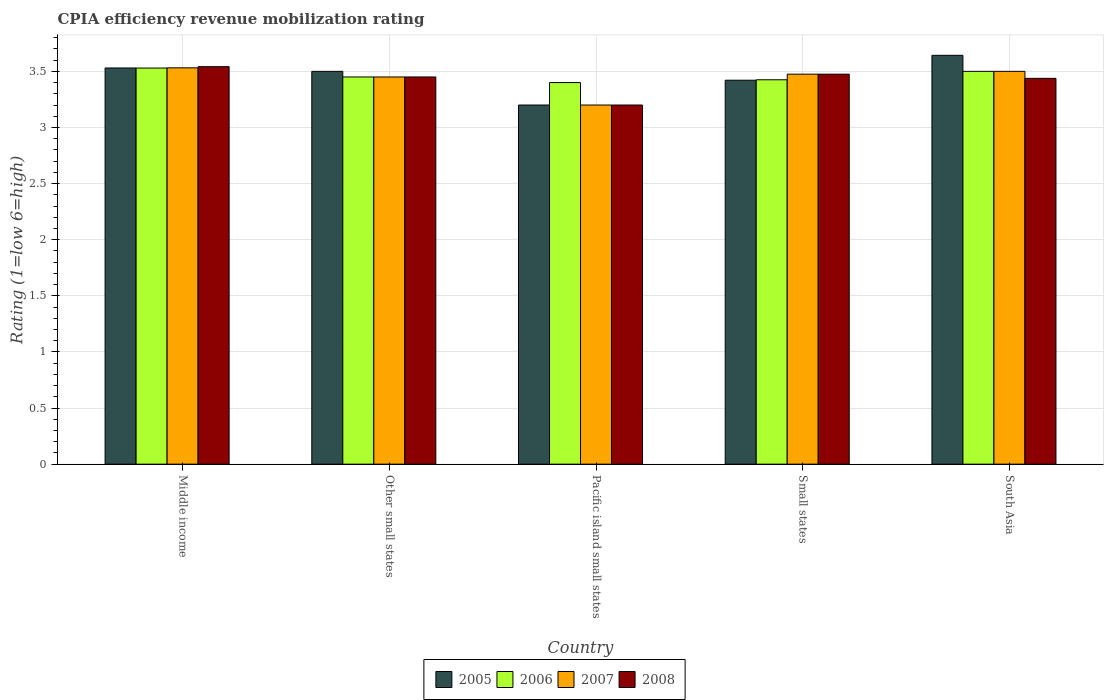How many different coloured bars are there?
Provide a succinct answer. 4. How many groups of bars are there?
Keep it short and to the point. 5. Are the number of bars on each tick of the X-axis equal?
Your response must be concise. Yes. What is the label of the 3rd group of bars from the left?
Offer a very short reply. Pacific island small states. In how many cases, is the number of bars for a given country not equal to the number of legend labels?
Your response must be concise. 0. Across all countries, what is the maximum CPIA rating in 2006?
Offer a terse response. 3.53. In which country was the CPIA rating in 2007 minimum?
Your response must be concise. Pacific island small states. What is the total CPIA rating in 2005 in the graph?
Keep it short and to the point. 17.29. What is the difference between the CPIA rating in 2006 in Middle income and that in Pacific island small states?
Your answer should be compact. 0.13. What is the difference between the CPIA rating in 2006 in South Asia and the CPIA rating in 2008 in Other small states?
Your answer should be compact. 0.05. What is the average CPIA rating in 2005 per country?
Offer a terse response. 3.46. What is the ratio of the CPIA rating in 2005 in Small states to that in South Asia?
Provide a short and direct response. 0.94. Is the CPIA rating in 2005 in Middle income less than that in South Asia?
Your response must be concise. Yes. Is the difference between the CPIA rating in 2008 in Middle income and Pacific island small states greater than the difference between the CPIA rating in 2007 in Middle income and Pacific island small states?
Provide a succinct answer. Yes. What is the difference between the highest and the second highest CPIA rating in 2006?
Ensure brevity in your answer.  -0.03. What is the difference between the highest and the lowest CPIA rating in 2008?
Your answer should be very brief. 0.34. In how many countries, is the CPIA rating in 2006 greater than the average CPIA rating in 2006 taken over all countries?
Provide a short and direct response. 2. What does the 1st bar from the left in Small states represents?
Ensure brevity in your answer.  2005. What does the 4th bar from the right in South Asia represents?
Your response must be concise. 2005. Is it the case that in every country, the sum of the CPIA rating in 2006 and CPIA rating in 2005 is greater than the CPIA rating in 2007?
Your response must be concise. Yes. What is the difference between two consecutive major ticks on the Y-axis?
Your answer should be very brief. 0.5. Are the values on the major ticks of Y-axis written in scientific E-notation?
Your response must be concise. No. Does the graph contain grids?
Your response must be concise. Yes. Where does the legend appear in the graph?
Provide a short and direct response. Bottom center. How are the legend labels stacked?
Provide a short and direct response. Horizontal. What is the title of the graph?
Provide a short and direct response. CPIA efficiency revenue mobilization rating. What is the label or title of the Y-axis?
Provide a short and direct response. Rating (1=low 6=high). What is the Rating (1=low 6=high) in 2005 in Middle income?
Your answer should be very brief. 3.53. What is the Rating (1=low 6=high) of 2006 in Middle income?
Provide a succinct answer. 3.53. What is the Rating (1=low 6=high) of 2007 in Middle income?
Keep it short and to the point. 3.53. What is the Rating (1=low 6=high) in 2008 in Middle income?
Offer a terse response. 3.54. What is the Rating (1=low 6=high) of 2006 in Other small states?
Your answer should be compact. 3.45. What is the Rating (1=low 6=high) in 2007 in Other small states?
Your answer should be compact. 3.45. What is the Rating (1=low 6=high) in 2008 in Other small states?
Provide a succinct answer. 3.45. What is the Rating (1=low 6=high) in 2005 in Pacific island small states?
Make the answer very short. 3.2. What is the Rating (1=low 6=high) of 2007 in Pacific island small states?
Your response must be concise. 3.2. What is the Rating (1=low 6=high) of 2008 in Pacific island small states?
Your answer should be compact. 3.2. What is the Rating (1=low 6=high) of 2005 in Small states?
Provide a succinct answer. 3.42. What is the Rating (1=low 6=high) in 2006 in Small states?
Provide a succinct answer. 3.42. What is the Rating (1=low 6=high) of 2007 in Small states?
Offer a terse response. 3.48. What is the Rating (1=low 6=high) in 2008 in Small states?
Ensure brevity in your answer.  3.48. What is the Rating (1=low 6=high) of 2005 in South Asia?
Make the answer very short. 3.64. What is the Rating (1=low 6=high) of 2006 in South Asia?
Your answer should be compact. 3.5. What is the Rating (1=low 6=high) of 2008 in South Asia?
Offer a very short reply. 3.44. Across all countries, what is the maximum Rating (1=low 6=high) of 2005?
Provide a short and direct response. 3.64. Across all countries, what is the maximum Rating (1=low 6=high) in 2006?
Provide a succinct answer. 3.53. Across all countries, what is the maximum Rating (1=low 6=high) of 2007?
Offer a terse response. 3.53. Across all countries, what is the maximum Rating (1=low 6=high) of 2008?
Offer a terse response. 3.54. Across all countries, what is the minimum Rating (1=low 6=high) in 2006?
Make the answer very short. 3.4. What is the total Rating (1=low 6=high) of 2005 in the graph?
Make the answer very short. 17.29. What is the total Rating (1=low 6=high) of 2006 in the graph?
Your answer should be very brief. 17.3. What is the total Rating (1=low 6=high) of 2007 in the graph?
Your answer should be very brief. 17.16. What is the total Rating (1=low 6=high) in 2008 in the graph?
Your answer should be very brief. 17.1. What is the difference between the Rating (1=low 6=high) of 2006 in Middle income and that in Other small states?
Your answer should be compact. 0.08. What is the difference between the Rating (1=low 6=high) of 2007 in Middle income and that in Other small states?
Give a very brief answer. 0.08. What is the difference between the Rating (1=low 6=high) in 2008 in Middle income and that in Other small states?
Provide a succinct answer. 0.09. What is the difference between the Rating (1=low 6=high) of 2005 in Middle income and that in Pacific island small states?
Your response must be concise. 0.33. What is the difference between the Rating (1=low 6=high) in 2006 in Middle income and that in Pacific island small states?
Make the answer very short. 0.13. What is the difference between the Rating (1=low 6=high) of 2007 in Middle income and that in Pacific island small states?
Your answer should be very brief. 0.33. What is the difference between the Rating (1=low 6=high) in 2008 in Middle income and that in Pacific island small states?
Keep it short and to the point. 0.34. What is the difference between the Rating (1=low 6=high) of 2005 in Middle income and that in Small states?
Ensure brevity in your answer.  0.11. What is the difference between the Rating (1=low 6=high) of 2006 in Middle income and that in Small states?
Offer a very short reply. 0.1. What is the difference between the Rating (1=low 6=high) of 2007 in Middle income and that in Small states?
Your answer should be very brief. 0.06. What is the difference between the Rating (1=low 6=high) of 2008 in Middle income and that in Small states?
Make the answer very short. 0.07. What is the difference between the Rating (1=low 6=high) of 2005 in Middle income and that in South Asia?
Provide a succinct answer. -0.11. What is the difference between the Rating (1=low 6=high) of 2006 in Middle income and that in South Asia?
Ensure brevity in your answer.  0.03. What is the difference between the Rating (1=low 6=high) in 2007 in Middle income and that in South Asia?
Make the answer very short. 0.03. What is the difference between the Rating (1=low 6=high) in 2008 in Middle income and that in South Asia?
Your response must be concise. 0.1. What is the difference between the Rating (1=low 6=high) of 2006 in Other small states and that in Pacific island small states?
Provide a succinct answer. 0.05. What is the difference between the Rating (1=low 6=high) in 2008 in Other small states and that in Pacific island small states?
Give a very brief answer. 0.25. What is the difference between the Rating (1=low 6=high) in 2005 in Other small states and that in Small states?
Keep it short and to the point. 0.08. What is the difference between the Rating (1=low 6=high) of 2006 in Other small states and that in Small states?
Your response must be concise. 0.03. What is the difference between the Rating (1=low 6=high) of 2007 in Other small states and that in Small states?
Keep it short and to the point. -0.03. What is the difference between the Rating (1=low 6=high) of 2008 in Other small states and that in Small states?
Give a very brief answer. -0.03. What is the difference between the Rating (1=low 6=high) in 2005 in Other small states and that in South Asia?
Offer a terse response. -0.14. What is the difference between the Rating (1=low 6=high) in 2006 in Other small states and that in South Asia?
Offer a terse response. -0.05. What is the difference between the Rating (1=low 6=high) of 2007 in Other small states and that in South Asia?
Your answer should be very brief. -0.05. What is the difference between the Rating (1=low 6=high) in 2008 in Other small states and that in South Asia?
Give a very brief answer. 0.01. What is the difference between the Rating (1=low 6=high) of 2005 in Pacific island small states and that in Small states?
Provide a succinct answer. -0.22. What is the difference between the Rating (1=low 6=high) in 2006 in Pacific island small states and that in Small states?
Offer a very short reply. -0.03. What is the difference between the Rating (1=low 6=high) of 2007 in Pacific island small states and that in Small states?
Your response must be concise. -0.28. What is the difference between the Rating (1=low 6=high) in 2008 in Pacific island small states and that in Small states?
Offer a very short reply. -0.28. What is the difference between the Rating (1=low 6=high) of 2005 in Pacific island small states and that in South Asia?
Your answer should be compact. -0.44. What is the difference between the Rating (1=low 6=high) of 2008 in Pacific island small states and that in South Asia?
Keep it short and to the point. -0.24. What is the difference between the Rating (1=low 6=high) of 2005 in Small states and that in South Asia?
Ensure brevity in your answer.  -0.22. What is the difference between the Rating (1=low 6=high) of 2006 in Small states and that in South Asia?
Provide a short and direct response. -0.07. What is the difference between the Rating (1=low 6=high) in 2007 in Small states and that in South Asia?
Ensure brevity in your answer.  -0.03. What is the difference between the Rating (1=low 6=high) in 2008 in Small states and that in South Asia?
Provide a short and direct response. 0.04. What is the difference between the Rating (1=low 6=high) in 2005 in Middle income and the Rating (1=low 6=high) in 2006 in Other small states?
Your answer should be compact. 0.08. What is the difference between the Rating (1=low 6=high) of 2005 in Middle income and the Rating (1=low 6=high) of 2007 in Other small states?
Give a very brief answer. 0.08. What is the difference between the Rating (1=low 6=high) in 2006 in Middle income and the Rating (1=low 6=high) in 2007 in Other small states?
Your answer should be compact. 0.08. What is the difference between the Rating (1=low 6=high) of 2006 in Middle income and the Rating (1=low 6=high) of 2008 in Other small states?
Keep it short and to the point. 0.08. What is the difference between the Rating (1=low 6=high) in 2007 in Middle income and the Rating (1=low 6=high) in 2008 in Other small states?
Offer a very short reply. 0.08. What is the difference between the Rating (1=low 6=high) in 2005 in Middle income and the Rating (1=low 6=high) in 2006 in Pacific island small states?
Your answer should be very brief. 0.13. What is the difference between the Rating (1=low 6=high) in 2005 in Middle income and the Rating (1=low 6=high) in 2007 in Pacific island small states?
Offer a very short reply. 0.33. What is the difference between the Rating (1=low 6=high) in 2005 in Middle income and the Rating (1=low 6=high) in 2008 in Pacific island small states?
Your response must be concise. 0.33. What is the difference between the Rating (1=low 6=high) of 2006 in Middle income and the Rating (1=low 6=high) of 2007 in Pacific island small states?
Make the answer very short. 0.33. What is the difference between the Rating (1=low 6=high) in 2006 in Middle income and the Rating (1=low 6=high) in 2008 in Pacific island small states?
Provide a succinct answer. 0.33. What is the difference between the Rating (1=low 6=high) in 2007 in Middle income and the Rating (1=low 6=high) in 2008 in Pacific island small states?
Your response must be concise. 0.33. What is the difference between the Rating (1=low 6=high) of 2005 in Middle income and the Rating (1=low 6=high) of 2006 in Small states?
Offer a terse response. 0.1. What is the difference between the Rating (1=low 6=high) in 2005 in Middle income and the Rating (1=low 6=high) in 2007 in Small states?
Make the answer very short. 0.06. What is the difference between the Rating (1=low 6=high) in 2005 in Middle income and the Rating (1=low 6=high) in 2008 in Small states?
Offer a very short reply. 0.06. What is the difference between the Rating (1=low 6=high) of 2006 in Middle income and the Rating (1=low 6=high) of 2007 in Small states?
Offer a very short reply. 0.05. What is the difference between the Rating (1=low 6=high) of 2006 in Middle income and the Rating (1=low 6=high) of 2008 in Small states?
Provide a succinct answer. 0.05. What is the difference between the Rating (1=low 6=high) in 2007 in Middle income and the Rating (1=low 6=high) in 2008 in Small states?
Give a very brief answer. 0.06. What is the difference between the Rating (1=low 6=high) of 2005 in Middle income and the Rating (1=low 6=high) of 2006 in South Asia?
Ensure brevity in your answer.  0.03. What is the difference between the Rating (1=low 6=high) of 2005 in Middle income and the Rating (1=low 6=high) of 2007 in South Asia?
Your answer should be compact. 0.03. What is the difference between the Rating (1=low 6=high) of 2005 in Middle income and the Rating (1=low 6=high) of 2008 in South Asia?
Your answer should be compact. 0.09. What is the difference between the Rating (1=low 6=high) of 2006 in Middle income and the Rating (1=low 6=high) of 2007 in South Asia?
Offer a terse response. 0.03. What is the difference between the Rating (1=low 6=high) in 2006 in Middle income and the Rating (1=low 6=high) in 2008 in South Asia?
Give a very brief answer. 0.09. What is the difference between the Rating (1=low 6=high) in 2007 in Middle income and the Rating (1=low 6=high) in 2008 in South Asia?
Your answer should be compact. 0.09. What is the difference between the Rating (1=low 6=high) of 2005 in Other small states and the Rating (1=low 6=high) of 2006 in Pacific island small states?
Give a very brief answer. 0.1. What is the difference between the Rating (1=low 6=high) in 2005 in Other small states and the Rating (1=low 6=high) in 2007 in Pacific island small states?
Provide a succinct answer. 0.3. What is the difference between the Rating (1=low 6=high) in 2006 in Other small states and the Rating (1=low 6=high) in 2008 in Pacific island small states?
Keep it short and to the point. 0.25. What is the difference between the Rating (1=low 6=high) in 2007 in Other small states and the Rating (1=low 6=high) in 2008 in Pacific island small states?
Ensure brevity in your answer.  0.25. What is the difference between the Rating (1=low 6=high) of 2005 in Other small states and the Rating (1=low 6=high) of 2006 in Small states?
Make the answer very short. 0.07. What is the difference between the Rating (1=low 6=high) of 2005 in Other small states and the Rating (1=low 6=high) of 2007 in Small states?
Offer a terse response. 0.03. What is the difference between the Rating (1=low 6=high) of 2005 in Other small states and the Rating (1=low 6=high) of 2008 in Small states?
Your answer should be very brief. 0.03. What is the difference between the Rating (1=low 6=high) in 2006 in Other small states and the Rating (1=low 6=high) in 2007 in Small states?
Provide a short and direct response. -0.03. What is the difference between the Rating (1=low 6=high) in 2006 in Other small states and the Rating (1=low 6=high) in 2008 in Small states?
Provide a short and direct response. -0.03. What is the difference between the Rating (1=low 6=high) in 2007 in Other small states and the Rating (1=low 6=high) in 2008 in Small states?
Your answer should be compact. -0.03. What is the difference between the Rating (1=low 6=high) in 2005 in Other small states and the Rating (1=low 6=high) in 2006 in South Asia?
Offer a very short reply. 0. What is the difference between the Rating (1=low 6=high) in 2005 in Other small states and the Rating (1=low 6=high) in 2007 in South Asia?
Provide a succinct answer. 0. What is the difference between the Rating (1=low 6=high) of 2005 in Other small states and the Rating (1=low 6=high) of 2008 in South Asia?
Make the answer very short. 0.06. What is the difference between the Rating (1=low 6=high) in 2006 in Other small states and the Rating (1=low 6=high) in 2008 in South Asia?
Your answer should be compact. 0.01. What is the difference between the Rating (1=low 6=high) in 2007 in Other small states and the Rating (1=low 6=high) in 2008 in South Asia?
Keep it short and to the point. 0.01. What is the difference between the Rating (1=low 6=high) of 2005 in Pacific island small states and the Rating (1=low 6=high) of 2006 in Small states?
Provide a short and direct response. -0.23. What is the difference between the Rating (1=low 6=high) in 2005 in Pacific island small states and the Rating (1=low 6=high) in 2007 in Small states?
Offer a very short reply. -0.28. What is the difference between the Rating (1=low 6=high) in 2005 in Pacific island small states and the Rating (1=low 6=high) in 2008 in Small states?
Provide a succinct answer. -0.28. What is the difference between the Rating (1=low 6=high) in 2006 in Pacific island small states and the Rating (1=low 6=high) in 2007 in Small states?
Ensure brevity in your answer.  -0.07. What is the difference between the Rating (1=low 6=high) of 2006 in Pacific island small states and the Rating (1=low 6=high) of 2008 in Small states?
Provide a succinct answer. -0.07. What is the difference between the Rating (1=low 6=high) in 2007 in Pacific island small states and the Rating (1=low 6=high) in 2008 in Small states?
Your answer should be compact. -0.28. What is the difference between the Rating (1=low 6=high) of 2005 in Pacific island small states and the Rating (1=low 6=high) of 2007 in South Asia?
Provide a short and direct response. -0.3. What is the difference between the Rating (1=low 6=high) of 2005 in Pacific island small states and the Rating (1=low 6=high) of 2008 in South Asia?
Your response must be concise. -0.24. What is the difference between the Rating (1=low 6=high) in 2006 in Pacific island small states and the Rating (1=low 6=high) in 2008 in South Asia?
Keep it short and to the point. -0.04. What is the difference between the Rating (1=low 6=high) of 2007 in Pacific island small states and the Rating (1=low 6=high) of 2008 in South Asia?
Offer a very short reply. -0.24. What is the difference between the Rating (1=low 6=high) of 2005 in Small states and the Rating (1=low 6=high) of 2006 in South Asia?
Provide a short and direct response. -0.08. What is the difference between the Rating (1=low 6=high) of 2005 in Small states and the Rating (1=low 6=high) of 2007 in South Asia?
Offer a terse response. -0.08. What is the difference between the Rating (1=low 6=high) in 2005 in Small states and the Rating (1=low 6=high) in 2008 in South Asia?
Ensure brevity in your answer.  -0.02. What is the difference between the Rating (1=low 6=high) of 2006 in Small states and the Rating (1=low 6=high) of 2007 in South Asia?
Ensure brevity in your answer.  -0.07. What is the difference between the Rating (1=low 6=high) in 2006 in Small states and the Rating (1=low 6=high) in 2008 in South Asia?
Your response must be concise. -0.01. What is the difference between the Rating (1=low 6=high) in 2007 in Small states and the Rating (1=low 6=high) in 2008 in South Asia?
Offer a terse response. 0.04. What is the average Rating (1=low 6=high) in 2005 per country?
Your response must be concise. 3.46. What is the average Rating (1=low 6=high) of 2006 per country?
Keep it short and to the point. 3.46. What is the average Rating (1=low 6=high) in 2007 per country?
Provide a short and direct response. 3.43. What is the average Rating (1=low 6=high) in 2008 per country?
Offer a very short reply. 3.42. What is the difference between the Rating (1=low 6=high) of 2005 and Rating (1=low 6=high) of 2006 in Middle income?
Ensure brevity in your answer.  0. What is the difference between the Rating (1=low 6=high) in 2005 and Rating (1=low 6=high) in 2007 in Middle income?
Offer a terse response. -0. What is the difference between the Rating (1=low 6=high) in 2005 and Rating (1=low 6=high) in 2008 in Middle income?
Keep it short and to the point. -0.01. What is the difference between the Rating (1=low 6=high) of 2006 and Rating (1=low 6=high) of 2007 in Middle income?
Ensure brevity in your answer.  -0. What is the difference between the Rating (1=low 6=high) of 2006 and Rating (1=low 6=high) of 2008 in Middle income?
Offer a terse response. -0.01. What is the difference between the Rating (1=low 6=high) of 2007 and Rating (1=low 6=high) of 2008 in Middle income?
Offer a terse response. -0.01. What is the difference between the Rating (1=low 6=high) in 2005 and Rating (1=low 6=high) in 2006 in Other small states?
Give a very brief answer. 0.05. What is the difference between the Rating (1=low 6=high) of 2006 and Rating (1=low 6=high) of 2007 in Other small states?
Provide a succinct answer. 0. What is the difference between the Rating (1=low 6=high) in 2007 and Rating (1=low 6=high) in 2008 in Other small states?
Make the answer very short. 0. What is the difference between the Rating (1=low 6=high) in 2005 and Rating (1=low 6=high) in 2007 in Pacific island small states?
Your response must be concise. 0. What is the difference between the Rating (1=low 6=high) of 2005 and Rating (1=low 6=high) of 2008 in Pacific island small states?
Offer a very short reply. 0. What is the difference between the Rating (1=low 6=high) in 2006 and Rating (1=low 6=high) in 2007 in Pacific island small states?
Give a very brief answer. 0.2. What is the difference between the Rating (1=low 6=high) in 2006 and Rating (1=low 6=high) in 2008 in Pacific island small states?
Provide a short and direct response. 0.2. What is the difference between the Rating (1=low 6=high) of 2007 and Rating (1=low 6=high) of 2008 in Pacific island small states?
Give a very brief answer. 0. What is the difference between the Rating (1=low 6=high) of 2005 and Rating (1=low 6=high) of 2006 in Small states?
Offer a very short reply. -0. What is the difference between the Rating (1=low 6=high) of 2005 and Rating (1=low 6=high) of 2007 in Small states?
Keep it short and to the point. -0.05. What is the difference between the Rating (1=low 6=high) of 2005 and Rating (1=low 6=high) of 2008 in Small states?
Your answer should be compact. -0.05. What is the difference between the Rating (1=low 6=high) of 2005 and Rating (1=low 6=high) of 2006 in South Asia?
Your response must be concise. 0.14. What is the difference between the Rating (1=low 6=high) of 2005 and Rating (1=low 6=high) of 2007 in South Asia?
Keep it short and to the point. 0.14. What is the difference between the Rating (1=low 6=high) of 2005 and Rating (1=low 6=high) of 2008 in South Asia?
Ensure brevity in your answer.  0.21. What is the difference between the Rating (1=low 6=high) in 2006 and Rating (1=low 6=high) in 2007 in South Asia?
Your answer should be compact. 0. What is the difference between the Rating (1=low 6=high) in 2006 and Rating (1=low 6=high) in 2008 in South Asia?
Provide a succinct answer. 0.06. What is the difference between the Rating (1=low 6=high) of 2007 and Rating (1=low 6=high) of 2008 in South Asia?
Ensure brevity in your answer.  0.06. What is the ratio of the Rating (1=low 6=high) of 2005 in Middle income to that in Other small states?
Your response must be concise. 1.01. What is the ratio of the Rating (1=low 6=high) in 2007 in Middle income to that in Other small states?
Provide a succinct answer. 1.02. What is the ratio of the Rating (1=low 6=high) of 2008 in Middle income to that in Other small states?
Provide a succinct answer. 1.03. What is the ratio of the Rating (1=low 6=high) in 2005 in Middle income to that in Pacific island small states?
Give a very brief answer. 1.1. What is the ratio of the Rating (1=low 6=high) in 2006 in Middle income to that in Pacific island small states?
Offer a terse response. 1.04. What is the ratio of the Rating (1=low 6=high) of 2007 in Middle income to that in Pacific island small states?
Offer a terse response. 1.1. What is the ratio of the Rating (1=low 6=high) in 2008 in Middle income to that in Pacific island small states?
Make the answer very short. 1.11. What is the ratio of the Rating (1=low 6=high) in 2005 in Middle income to that in Small states?
Your response must be concise. 1.03. What is the ratio of the Rating (1=low 6=high) of 2006 in Middle income to that in Small states?
Your answer should be very brief. 1.03. What is the ratio of the Rating (1=low 6=high) of 2007 in Middle income to that in Small states?
Offer a terse response. 1.02. What is the ratio of the Rating (1=low 6=high) of 2008 in Middle income to that in Small states?
Keep it short and to the point. 1.02. What is the ratio of the Rating (1=low 6=high) in 2006 in Middle income to that in South Asia?
Your response must be concise. 1.01. What is the ratio of the Rating (1=low 6=high) of 2007 in Middle income to that in South Asia?
Keep it short and to the point. 1.01. What is the ratio of the Rating (1=low 6=high) in 2008 in Middle income to that in South Asia?
Offer a terse response. 1.03. What is the ratio of the Rating (1=low 6=high) of 2005 in Other small states to that in Pacific island small states?
Your answer should be compact. 1.09. What is the ratio of the Rating (1=low 6=high) of 2006 in Other small states to that in Pacific island small states?
Make the answer very short. 1.01. What is the ratio of the Rating (1=low 6=high) in 2007 in Other small states to that in Pacific island small states?
Offer a terse response. 1.08. What is the ratio of the Rating (1=low 6=high) of 2008 in Other small states to that in Pacific island small states?
Provide a succinct answer. 1.08. What is the ratio of the Rating (1=low 6=high) in 2005 in Other small states to that in Small states?
Your response must be concise. 1.02. What is the ratio of the Rating (1=low 6=high) of 2006 in Other small states to that in Small states?
Keep it short and to the point. 1.01. What is the ratio of the Rating (1=low 6=high) in 2007 in Other small states to that in Small states?
Provide a succinct answer. 0.99. What is the ratio of the Rating (1=low 6=high) of 2005 in Other small states to that in South Asia?
Make the answer very short. 0.96. What is the ratio of the Rating (1=low 6=high) of 2006 in Other small states to that in South Asia?
Offer a very short reply. 0.99. What is the ratio of the Rating (1=low 6=high) in 2007 in Other small states to that in South Asia?
Keep it short and to the point. 0.99. What is the ratio of the Rating (1=low 6=high) of 2005 in Pacific island small states to that in Small states?
Keep it short and to the point. 0.94. What is the ratio of the Rating (1=low 6=high) in 2006 in Pacific island small states to that in Small states?
Make the answer very short. 0.99. What is the ratio of the Rating (1=low 6=high) of 2007 in Pacific island small states to that in Small states?
Keep it short and to the point. 0.92. What is the ratio of the Rating (1=low 6=high) in 2008 in Pacific island small states to that in Small states?
Make the answer very short. 0.92. What is the ratio of the Rating (1=low 6=high) of 2005 in Pacific island small states to that in South Asia?
Ensure brevity in your answer.  0.88. What is the ratio of the Rating (1=low 6=high) of 2006 in Pacific island small states to that in South Asia?
Your answer should be compact. 0.97. What is the ratio of the Rating (1=low 6=high) of 2007 in Pacific island small states to that in South Asia?
Provide a short and direct response. 0.91. What is the ratio of the Rating (1=low 6=high) of 2008 in Pacific island small states to that in South Asia?
Keep it short and to the point. 0.93. What is the ratio of the Rating (1=low 6=high) in 2005 in Small states to that in South Asia?
Your response must be concise. 0.94. What is the ratio of the Rating (1=low 6=high) of 2006 in Small states to that in South Asia?
Offer a very short reply. 0.98. What is the ratio of the Rating (1=low 6=high) in 2008 in Small states to that in South Asia?
Make the answer very short. 1.01. What is the difference between the highest and the second highest Rating (1=low 6=high) of 2005?
Your response must be concise. 0.11. What is the difference between the highest and the second highest Rating (1=low 6=high) of 2006?
Keep it short and to the point. 0.03. What is the difference between the highest and the second highest Rating (1=low 6=high) in 2007?
Provide a succinct answer. 0.03. What is the difference between the highest and the second highest Rating (1=low 6=high) in 2008?
Your response must be concise. 0.07. What is the difference between the highest and the lowest Rating (1=low 6=high) in 2005?
Your response must be concise. 0.44. What is the difference between the highest and the lowest Rating (1=low 6=high) in 2006?
Your answer should be compact. 0.13. What is the difference between the highest and the lowest Rating (1=low 6=high) in 2007?
Ensure brevity in your answer.  0.33. What is the difference between the highest and the lowest Rating (1=low 6=high) in 2008?
Your response must be concise. 0.34. 